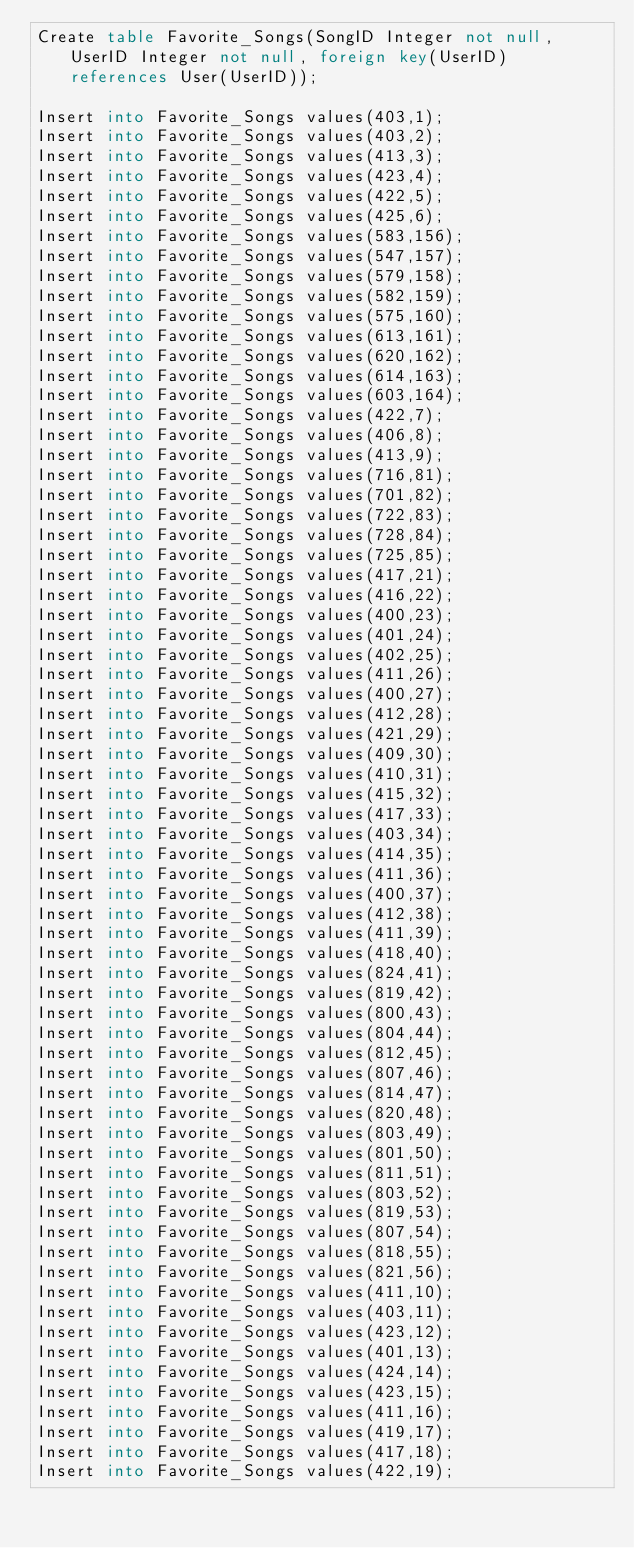Convert code to text. <code><loc_0><loc_0><loc_500><loc_500><_SQL_>Create table Favorite_Songs(SongID Integer not null, UserID Integer not null, foreign key(UserID) references User(UserID));

Insert into Favorite_Songs values(403,1);
Insert into Favorite_Songs values(403,2);
Insert into Favorite_Songs values(413,3);
Insert into Favorite_Songs values(423,4);
Insert into Favorite_Songs values(422,5);
Insert into Favorite_Songs values(425,6);
Insert into Favorite_Songs values(583,156);
Insert into Favorite_Songs values(547,157);
Insert into Favorite_Songs values(579,158);
Insert into Favorite_Songs values(582,159);
Insert into Favorite_Songs values(575,160);
Insert into Favorite_Songs values(613,161);
Insert into Favorite_Songs values(620,162);
Insert into Favorite_Songs values(614,163);
Insert into Favorite_Songs values(603,164);
Insert into Favorite_Songs values(422,7);
Insert into Favorite_Songs values(406,8);
Insert into Favorite_Songs values(413,9);
Insert into Favorite_Songs values(716,81);
Insert into Favorite_Songs values(701,82);
Insert into Favorite_Songs values(722,83);
Insert into Favorite_Songs values(728,84);
Insert into Favorite_Songs values(725,85);
Insert into Favorite_Songs values(417,21);
Insert into Favorite_Songs values(416,22);
Insert into Favorite_Songs values(400,23);
Insert into Favorite_Songs values(401,24);
Insert into Favorite_Songs values(402,25);
Insert into Favorite_Songs values(411,26);
Insert into Favorite_Songs values(400,27);
Insert into Favorite_Songs values(412,28);
Insert into Favorite_Songs values(421,29);
Insert into Favorite_Songs values(409,30);
Insert into Favorite_Songs values(410,31);
Insert into Favorite_Songs values(415,32);
Insert into Favorite_Songs values(417,33);
Insert into Favorite_Songs values(403,34);
Insert into Favorite_Songs values(414,35);
Insert into Favorite_Songs values(411,36);
Insert into Favorite_Songs values(400,37);
Insert into Favorite_Songs values(412,38);
Insert into Favorite_Songs values(411,39);
Insert into Favorite_Songs values(418,40);
Insert into Favorite_Songs values(824,41);
Insert into Favorite_Songs values(819,42);
Insert into Favorite_Songs values(800,43);
Insert into Favorite_Songs values(804,44);
Insert into Favorite_Songs values(812,45);
Insert into Favorite_Songs values(807,46);
Insert into Favorite_Songs values(814,47);
Insert into Favorite_Songs values(820,48);
Insert into Favorite_Songs values(803,49);
Insert into Favorite_Songs values(801,50);
Insert into Favorite_Songs values(811,51);
Insert into Favorite_Songs values(803,52);
Insert into Favorite_Songs values(819,53);
Insert into Favorite_Songs values(807,54);
Insert into Favorite_Songs values(818,55);
Insert into Favorite_Songs values(821,56);
Insert into Favorite_Songs values(411,10);
Insert into Favorite_Songs values(403,11);
Insert into Favorite_Songs values(423,12);
Insert into Favorite_Songs values(401,13);
Insert into Favorite_Songs values(424,14);
Insert into Favorite_Songs values(423,15);
Insert into Favorite_Songs values(411,16);
Insert into Favorite_Songs values(419,17);
Insert into Favorite_Songs values(417,18);
Insert into Favorite_Songs values(422,19);</code> 